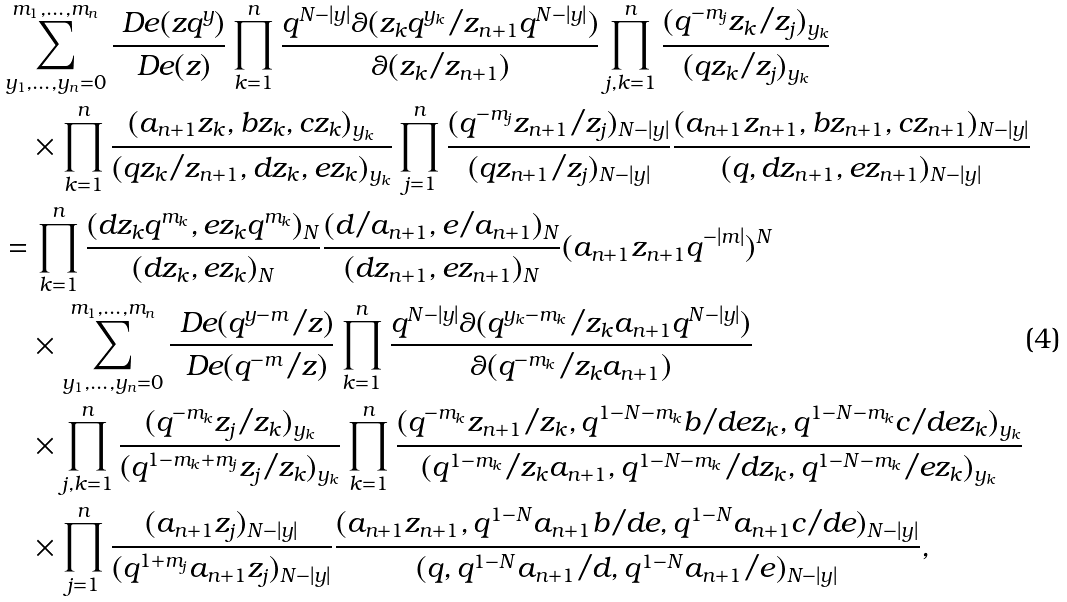<formula> <loc_0><loc_0><loc_500><loc_500>& \sum _ { y _ { 1 } , \dots , y _ { n } = 0 } ^ { m _ { 1 } , \dots , m _ { n } } \frac { \ D e ( z q ^ { y } ) } { \ D e ( z ) } \prod _ { k = 1 } ^ { n } \frac { q ^ { N - | y | } \theta ( z _ { k } q ^ { y _ { k } } / z _ { n + 1 } q ^ { N - | y | } ) } { \theta ( z _ { k } / z _ { n + 1 } ) } \prod _ { j , k = 1 } ^ { n } \frac { ( q ^ { - m _ { j } } z _ { k } / z _ { j } ) _ { y _ { k } } } { ( q z _ { k } / z _ { j } ) _ { y _ { k } } } \\ & \quad \times \prod _ { k = 1 } ^ { n } \frac { ( a _ { n + 1 } z _ { k } , b z _ { k } , c z _ { k } ) _ { y _ { k } } } { ( q z _ { k } / z _ { n + 1 } , d z _ { k } , e z _ { k } ) _ { y _ { k } } } \prod _ { j = 1 } ^ { n } \frac { ( q ^ { - m _ { j } } z _ { n + 1 } / z _ { j } ) _ { N - | y | } } { ( q z _ { n + 1 } / z _ { j } ) _ { N - | y | } } \frac { ( a _ { n + 1 } z _ { n + 1 } , b z _ { n + 1 } , c z _ { n + 1 } ) _ { N - | y | } } { ( q , d z _ { n + 1 } , e z _ { n + 1 } ) _ { N - | y | } } \\ & = \prod _ { k = 1 } ^ { n } \frac { ( d z _ { k } q ^ { m _ { k } } , e z _ { k } q ^ { m _ { k } } ) _ { N } } { ( d z _ { k } , e z _ { k } ) _ { N } } \frac { ( d / a _ { n + 1 } , e / a _ { n + 1 } ) _ { N } } { ( d z _ { n + 1 } , e z _ { n + 1 } ) _ { N } } ( a _ { n + 1 } z _ { n + 1 } q ^ { - | m | } ) ^ { N } \\ & \quad \times \sum _ { y _ { 1 } , \dots , y _ { n } = 0 } ^ { m _ { 1 } , \dots , m _ { n } } \frac { \ D e ( q ^ { y - m } / z ) } { \ D e ( q ^ { - m } / z ) } \prod _ { k = 1 } ^ { n } \frac { q ^ { N - | y | } \theta ( q ^ { y _ { k } - m _ { k } } / z _ { k } a _ { n + 1 } q ^ { N - | y | } ) } { \theta ( q ^ { - m _ { k } } / z _ { k } a _ { n + 1 } ) } \\ & \quad \times \prod _ { j , k = 1 } ^ { n } \frac { ( q ^ { - m _ { k } } z _ { j } / z _ { k } ) _ { y _ { k } } } { ( q ^ { 1 - m _ { k } + m _ { j } } z _ { j } / z _ { k } ) _ { y _ { k } } } \prod _ { k = 1 } ^ { n } \frac { ( q ^ { - m _ { k } } z _ { n + 1 } / z _ { k } , q ^ { 1 - N - m _ { k } } b / d e z _ { k } , q ^ { 1 - N - m _ { k } } c / d e z _ { k } ) _ { y _ { k } } } { ( q ^ { 1 - m _ { k } } / z _ { k } a _ { n + 1 } , q ^ { 1 - N - m _ { k } } / d z _ { k } , q ^ { 1 - N - m _ { k } } / e z _ { k } ) _ { y _ { k } } } \\ & \quad \times \prod _ { j = 1 } ^ { n } \frac { ( a _ { n + 1 } z _ { j } ) _ { N - | y | } } { ( q ^ { 1 + m _ { j } } a _ { n + 1 } z _ { j } ) _ { N - | y | } } \frac { ( a _ { n + 1 } z _ { n + 1 } , q ^ { 1 - N } a _ { n + 1 } b / d e , q ^ { 1 - N } a _ { n + 1 } c / d e ) _ { N - | y | } } { ( q , q ^ { 1 - N } a _ { n + 1 } / d , q ^ { 1 - N } a _ { n + 1 } / e ) _ { N - | y | } } ,</formula> 